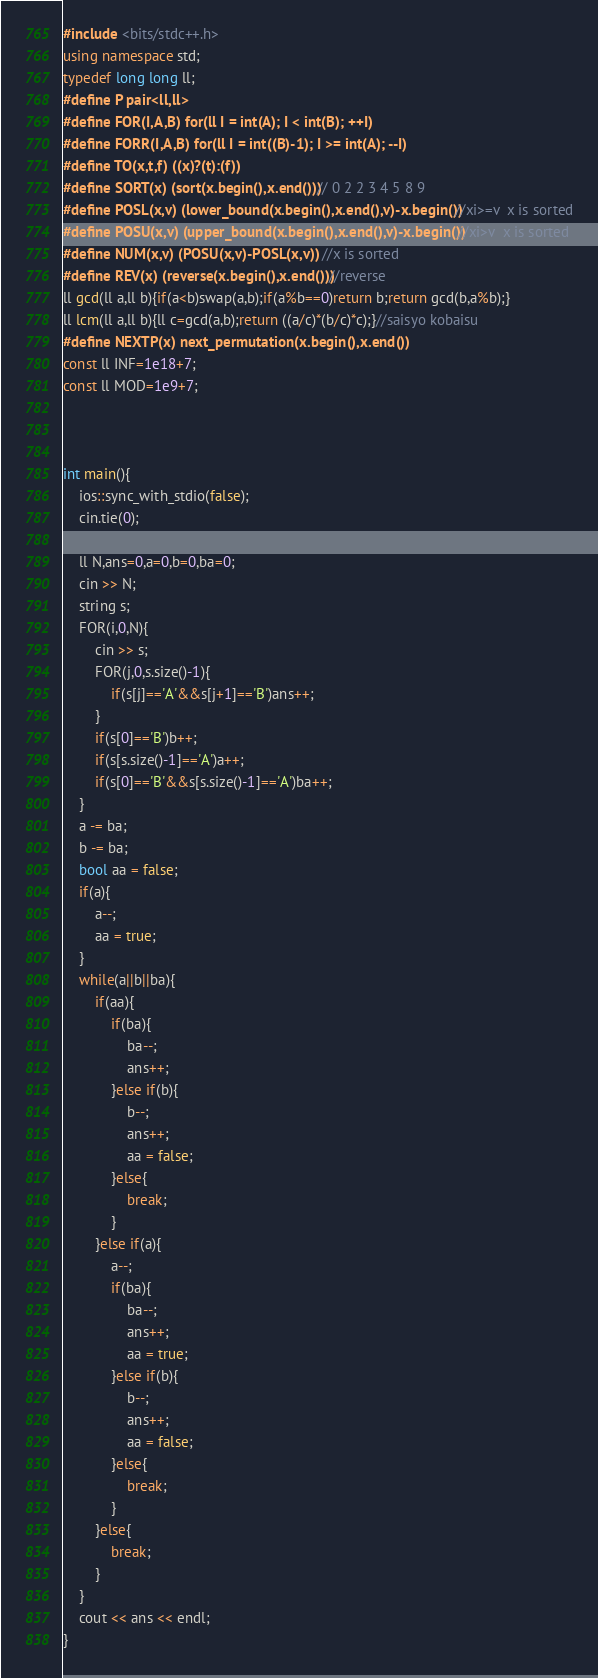<code> <loc_0><loc_0><loc_500><loc_500><_C++_>#include <bits/stdc++.h>
using namespace std;
typedef long long ll;
#define P pair<ll,ll>
#define FOR(I,A,B) for(ll I = int(A); I < int(B); ++I)
#define FORR(I,A,B) for(ll I = int((B)-1); I >= int(A); --I)
#define TO(x,t,f) ((x)?(t):(f))
#define SORT(x) (sort(x.begin(),x.end())) // 0 2 2 3 4 5 8 9
#define POSL(x,v) (lower_bound(x.begin(),x.end(),v)-x.begin()) //xi>=v  x is sorted
#define POSU(x,v) (upper_bound(x.begin(),x.end(),v)-x.begin()) //xi>v  x is sorted
#define NUM(x,v) (POSU(x,v)-POSL(x,v))  //x is sorted
#define REV(x) (reverse(x.begin(),x.end())) //reverse
ll gcd(ll a,ll b){if(a<b)swap(a,b);if(a%b==0)return b;return gcd(b,a%b);}
ll lcm(ll a,ll b){ll c=gcd(a,b);return ((a/c)*(b/c)*c);}//saisyo kobaisu
#define NEXTP(x) next_permutation(x.begin(),x.end())
const ll INF=1e18+7;
const ll MOD=1e9+7;



int main(){
	ios::sync_with_stdio(false);
	cin.tie(0);

	ll N,ans=0,a=0,b=0,ba=0;
	cin >> N;
	string s;
	FOR(i,0,N){
		cin >> s;
		FOR(j,0,s.size()-1){
			if(s[j]=='A'&&s[j+1]=='B')ans++;
		}
		if(s[0]=='B')b++;
		if(s[s.size()-1]=='A')a++;
		if(s[0]=='B'&&s[s.size()-1]=='A')ba++;
	}
	a -= ba;
	b -= ba;
	bool aa = false;
	if(a){
		a--;
		aa = true;
	}
	while(a||b||ba){
		if(aa){
			if(ba){
				ba--;
				ans++;
			}else if(b){
				b--;
				ans++;
				aa = false;
			}else{
				break;
			}
		}else if(a){
			a--;
			if(ba){
				ba--;
				ans++;
				aa = true;
			}else if(b){
				b--;
				ans++;
				aa = false;
			}else{
				break;
			}
		}else{
			break;
		}
	}
	cout << ans << endl;
}
</code> 